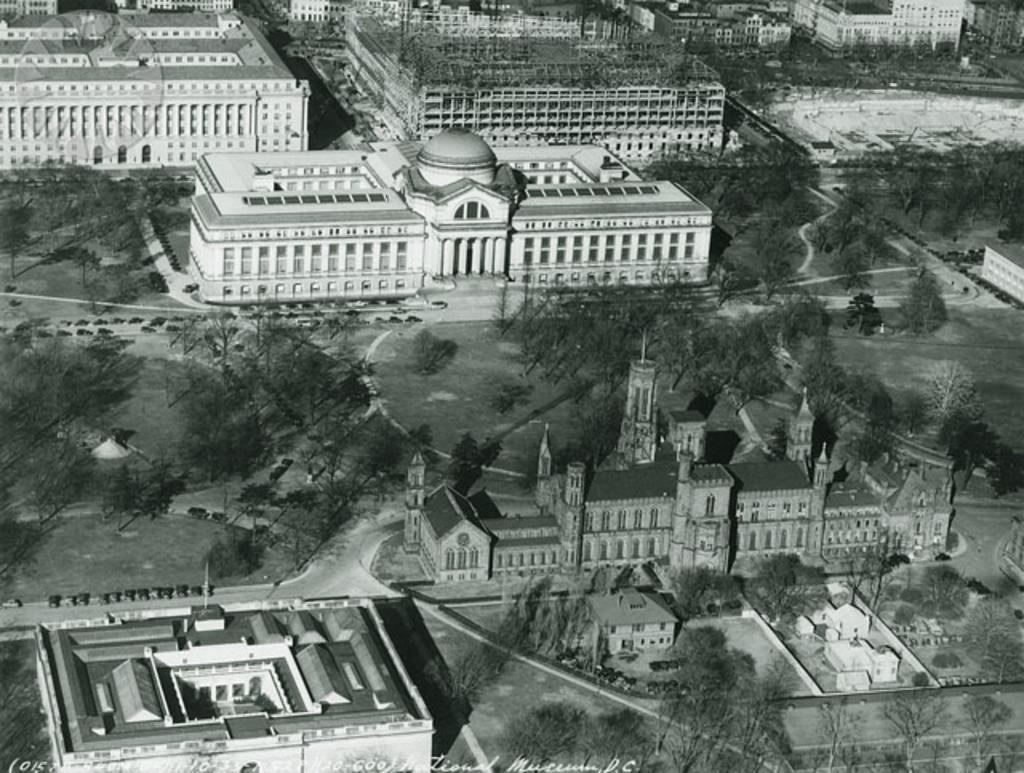What is the color scheme of the image? The image is black and white. What type of structures can be seen in the image? There is a group of buildings and houses in the image. What natural elements are present in the image? There is a group of trees in the image. What additional elements can be found in the image? There is a logo and text in the image. Is there a hot feast being served in the image? There is no indication of a hot feast being served in the image, as it primarily features buildings, houses, trees, a logo, and text. 